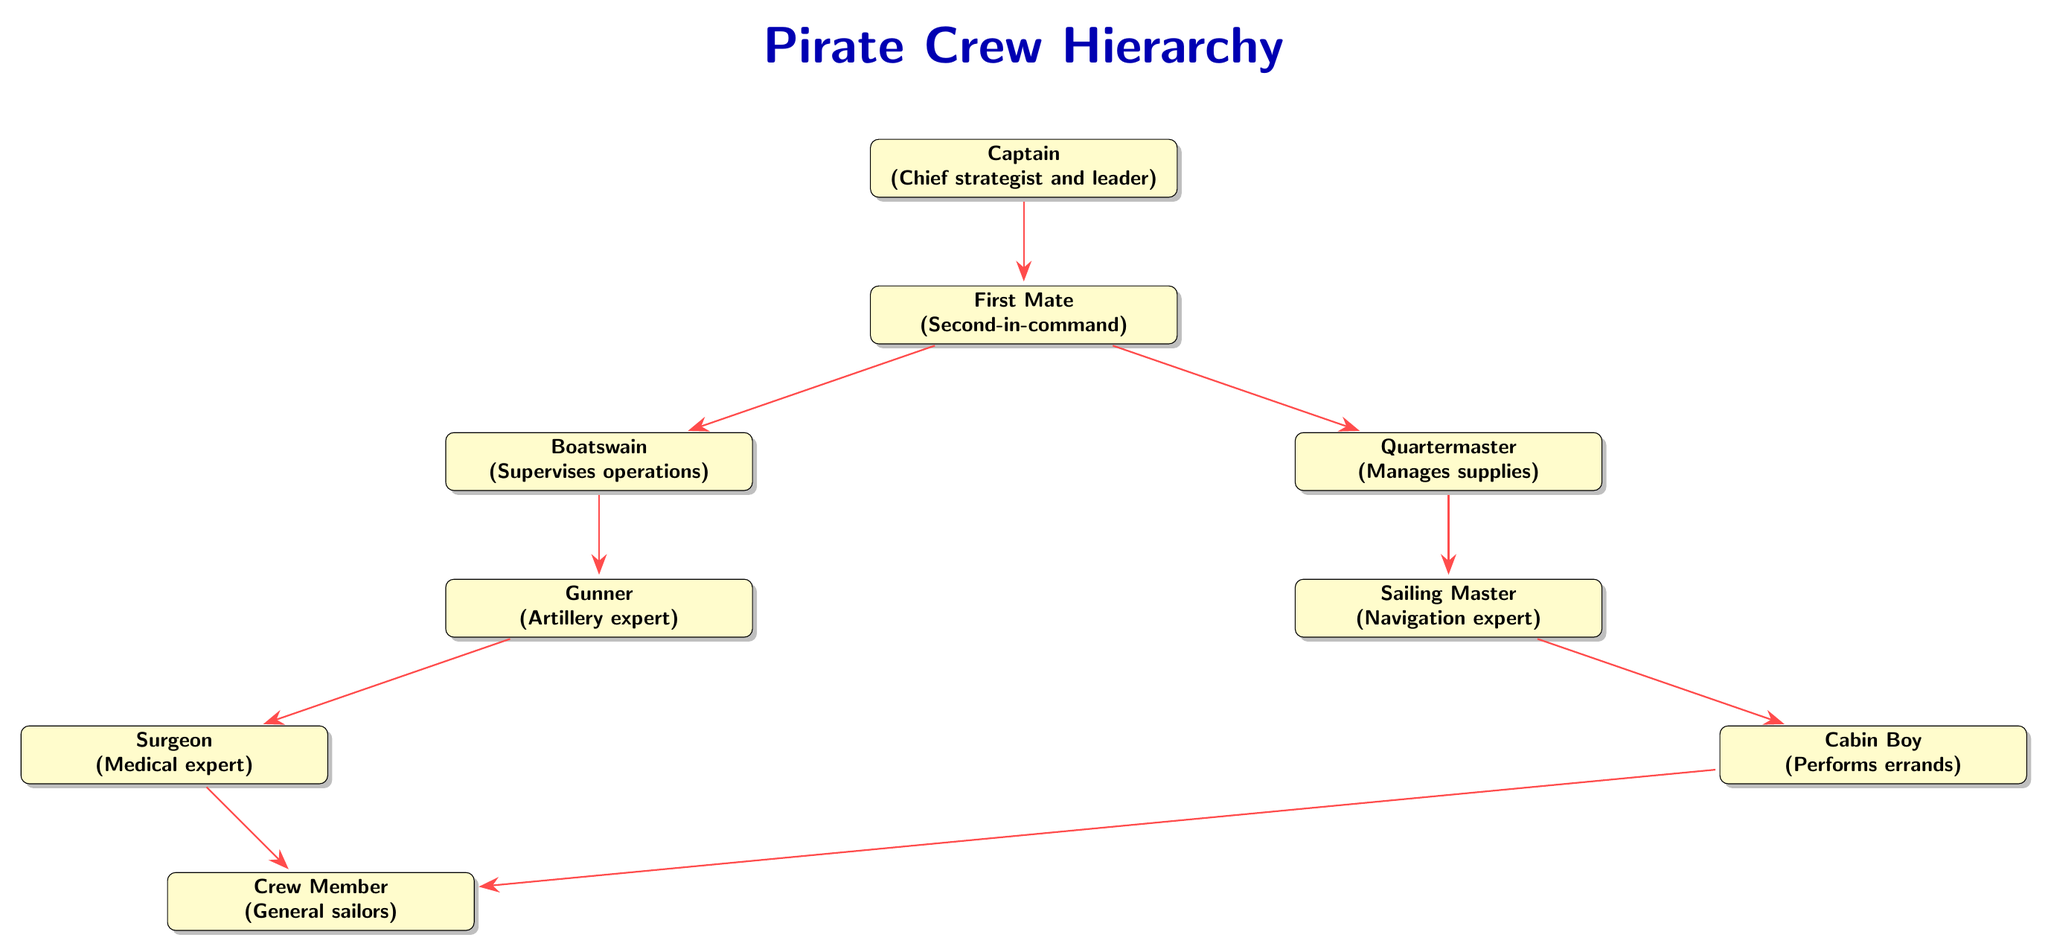What is the role of the Captain? The diagram indicates that the Captain is described as the chief strategist and leader of the pirate crew.
Answer: Chief strategist and leader Who is below the First Mate in the hierarchy? According to the diagram, the Boatswain and Quartermaster are both directly below the First Mate.
Answer: Boatswain and Quartermaster How many total nodes are present in the diagram? By counting each pirate role in the diagram, we identify a total of eight roles from Captain to Crew Member.
Answer: Eight What does the Quartermaster manage? The diagram specifies that the Quartermaster is responsible for managing supplies within the crew.
Answer: Supplies Who ranks above the Surgeon? In the hierarchy presented in the diagram, the Gunner ranks directly above the Surgeon.
Answer: Gunner Which role has the most responsibilities in the hierarchy? The Captain is depicted in the diagram with multiple connections, indicating the central role and strategic significance.
Answer: Captain What is the relationship between the Boatswain and the Gunner? The diagram shows that the Boatswain supervises operations and is directly connected to the Gunner as his subordinate.
Answer: Supervises operations Who performs errands according to the diagram? The diagram indicates that the Cabin Boy is responsible for performing errands within the crew.
Answer: Cabin Boy 